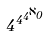<formula> <loc_0><loc_0><loc_500><loc_500>4 ^ { 4 ^ { 4 ^ { \aleph _ { 0 } } } }</formula> 